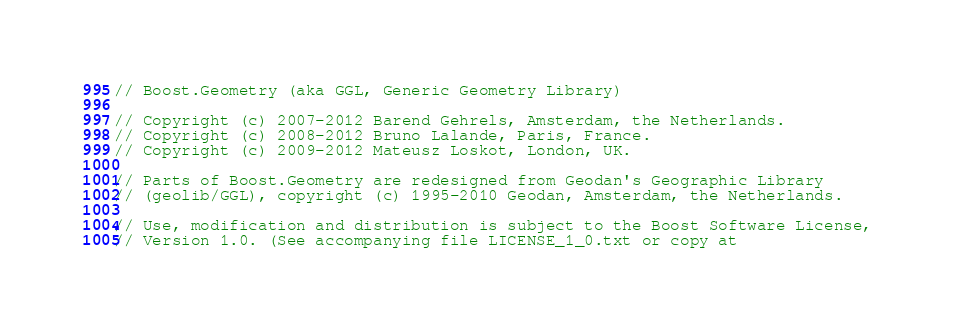Convert code to text. <code><loc_0><loc_0><loc_500><loc_500><_C++_>// Boost.Geometry (aka GGL, Generic Geometry Library)

// Copyright (c) 2007-2012 Barend Gehrels, Amsterdam, the Netherlands.
// Copyright (c) 2008-2012 Bruno Lalande, Paris, France.
// Copyright (c) 2009-2012 Mateusz Loskot, London, UK.

// Parts of Boost.Geometry are redesigned from Geodan's Geographic Library
// (geolib/GGL), copyright (c) 1995-2010 Geodan, Amsterdam, the Netherlands.

// Use, modification and distribution is subject to the Boost Software License,
// Version 1.0. (See accompanying file LICENSE_1_0.txt or copy at</code> 